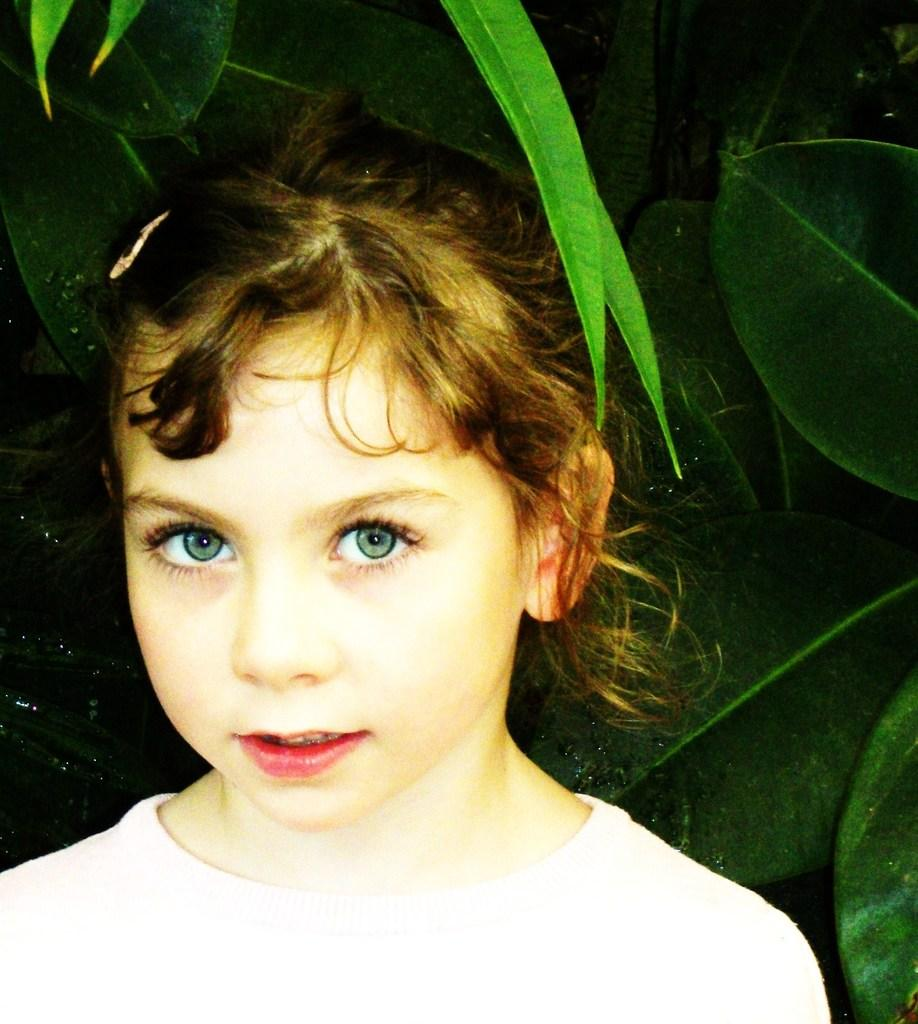Who is the main subject in the image? There is a girl in the image. What can be seen in the background of the image? There are leaves in the background of the image. What type of clock is hanging on the side of the girl in the image? There is no clock present in the image. 